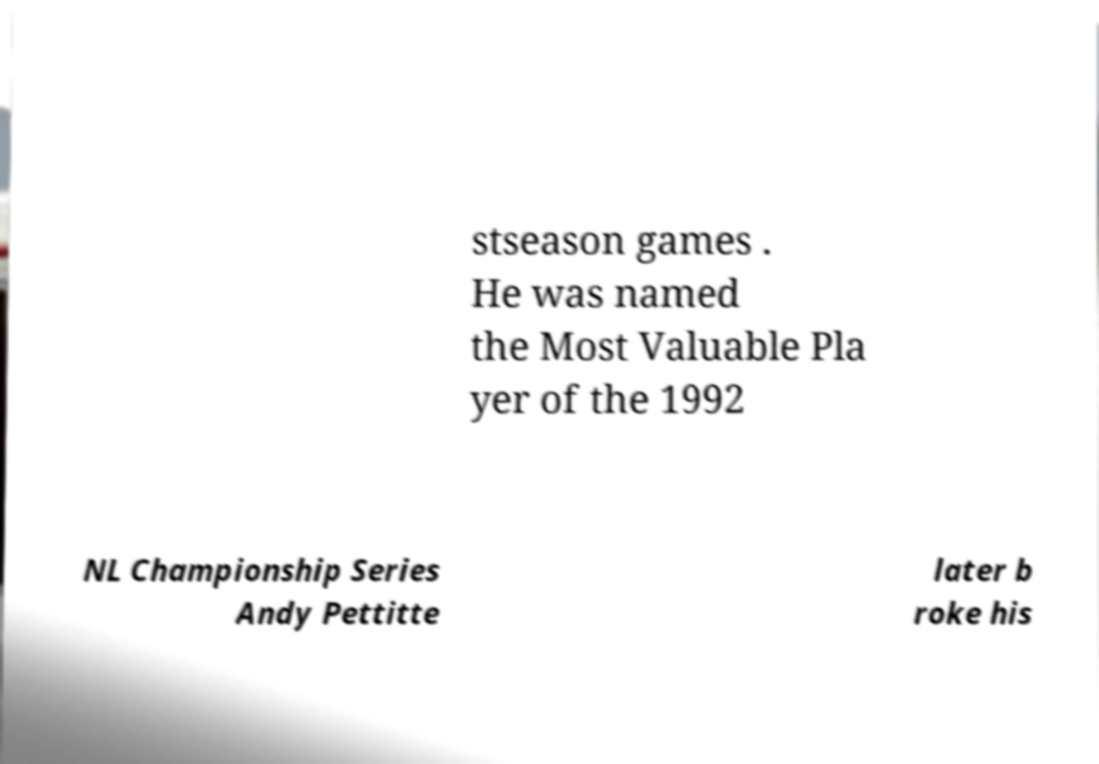What messages or text are displayed in this image? I need them in a readable, typed format. stseason games . He was named the Most Valuable Pla yer of the 1992 NL Championship Series Andy Pettitte later b roke his 